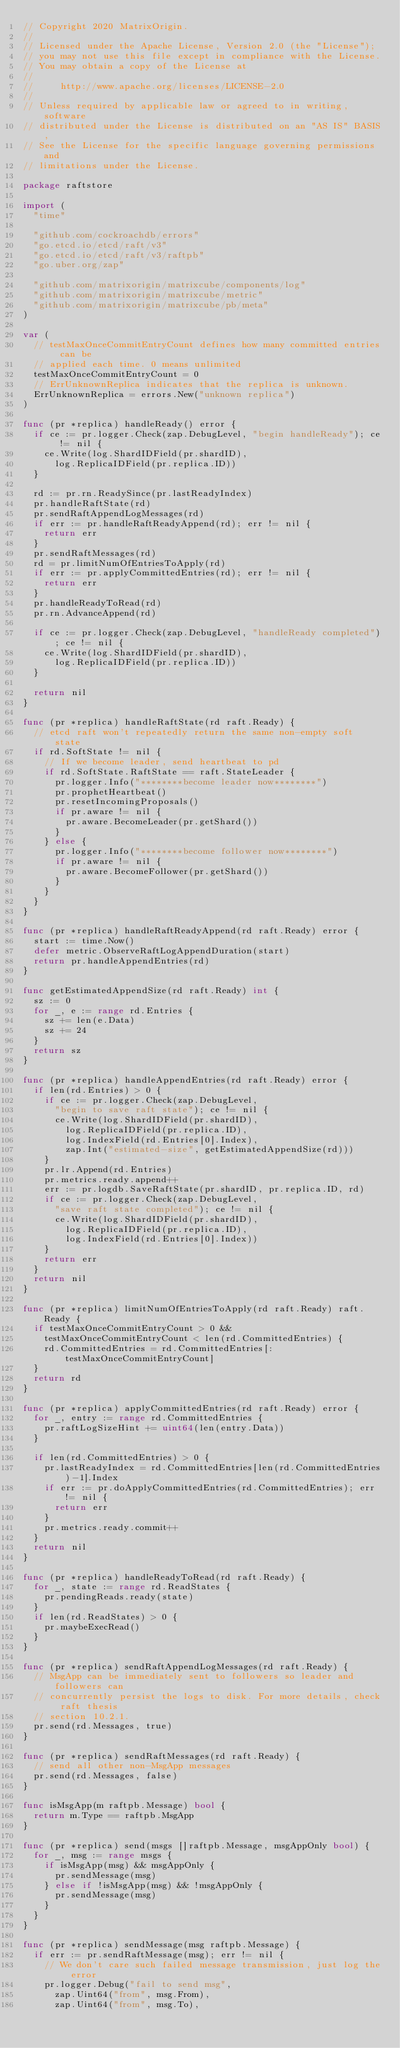Convert code to text. <code><loc_0><loc_0><loc_500><loc_500><_Go_>// Copyright 2020 MatrixOrigin.
//
// Licensed under the Apache License, Version 2.0 (the "License");
// you may not use this file except in compliance with the License.
// You may obtain a copy of the License at
//
//     http://www.apache.org/licenses/LICENSE-2.0
//
// Unless required by applicable law or agreed to in writing, software
// distributed under the License is distributed on an "AS IS" BASIS,
// See the License for the specific language governing permissions and
// limitations under the License.

package raftstore

import (
	"time"

	"github.com/cockroachdb/errors"
	"go.etcd.io/etcd/raft/v3"
	"go.etcd.io/etcd/raft/v3/raftpb"
	"go.uber.org/zap"

	"github.com/matrixorigin/matrixcube/components/log"
	"github.com/matrixorigin/matrixcube/metric"
	"github.com/matrixorigin/matrixcube/pb/meta"
)

var (
	// testMaxOnceCommitEntryCount defines how many committed entries can be
	// applied each time. 0 means unlimited
	testMaxOnceCommitEntryCount = 0
	// ErrUnknownReplica indicates that the replica is unknown.
	ErrUnknownReplica = errors.New("unknown replica")
)

func (pr *replica) handleReady() error {
	if ce := pr.logger.Check(zap.DebugLevel, "begin handleReady"); ce != nil {
		ce.Write(log.ShardIDField(pr.shardID),
			log.ReplicaIDField(pr.replica.ID))
	}

	rd := pr.rn.ReadySince(pr.lastReadyIndex)
	pr.handleRaftState(rd)
	pr.sendRaftAppendLogMessages(rd)
	if err := pr.handleRaftReadyAppend(rd); err != nil {
		return err
	}
	pr.sendRaftMessages(rd)
	rd = pr.limitNumOfEntriesToApply(rd)
	if err := pr.applyCommittedEntries(rd); err != nil {
		return err
	}
	pr.handleReadyToRead(rd)
	pr.rn.AdvanceAppend(rd)

	if ce := pr.logger.Check(zap.DebugLevel, "handleReady completed"); ce != nil {
		ce.Write(log.ShardIDField(pr.shardID),
			log.ReplicaIDField(pr.replica.ID))
	}

	return nil
}

func (pr *replica) handleRaftState(rd raft.Ready) {
	// etcd raft won't repeatedly return the same non-empty soft state
	if rd.SoftState != nil {
		// If we become leader, send heartbeat to pd
		if rd.SoftState.RaftState == raft.StateLeader {
			pr.logger.Info("********become leader now********")
			pr.prophetHeartbeat()
			pr.resetIncomingProposals()
			if pr.aware != nil {
				pr.aware.BecomeLeader(pr.getShard())
			}
		} else {
			pr.logger.Info("********become follower now********")
			if pr.aware != nil {
				pr.aware.BecomeFollower(pr.getShard())
			}
		}
	}
}

func (pr *replica) handleRaftReadyAppend(rd raft.Ready) error {
	start := time.Now()
	defer metric.ObserveRaftLogAppendDuration(start)
	return pr.handleAppendEntries(rd)
}

func getEstimatedAppendSize(rd raft.Ready) int {
	sz := 0
	for _, e := range rd.Entries {
		sz += len(e.Data)
		sz += 24
	}
	return sz
}

func (pr *replica) handleAppendEntries(rd raft.Ready) error {
	if len(rd.Entries) > 0 {
		if ce := pr.logger.Check(zap.DebugLevel,
			"begin to save raft state"); ce != nil {
			ce.Write(log.ShardIDField(pr.shardID),
				log.ReplicaIDField(pr.replica.ID),
				log.IndexField(rd.Entries[0].Index),
				zap.Int("estimated-size", getEstimatedAppendSize(rd)))
		}
		pr.lr.Append(rd.Entries)
		pr.metrics.ready.append++
		err := pr.logdb.SaveRaftState(pr.shardID, pr.replica.ID, rd)
		if ce := pr.logger.Check(zap.DebugLevel,
			"save raft state completed"); ce != nil {
			ce.Write(log.ShardIDField(pr.shardID),
				log.ReplicaIDField(pr.replica.ID),
				log.IndexField(rd.Entries[0].Index))
		}
		return err
	}
	return nil
}

func (pr *replica) limitNumOfEntriesToApply(rd raft.Ready) raft.Ready {
	if testMaxOnceCommitEntryCount > 0 &&
		testMaxOnceCommitEntryCount < len(rd.CommittedEntries) {
		rd.CommittedEntries = rd.CommittedEntries[:testMaxOnceCommitEntryCount]
	}
	return rd
}

func (pr *replica) applyCommittedEntries(rd raft.Ready) error {
	for _, entry := range rd.CommittedEntries {
		pr.raftLogSizeHint += uint64(len(entry.Data))
	}

	if len(rd.CommittedEntries) > 0 {
		pr.lastReadyIndex = rd.CommittedEntries[len(rd.CommittedEntries)-1].Index
		if err := pr.doApplyCommittedEntries(rd.CommittedEntries); err != nil {
			return err
		}
		pr.metrics.ready.commit++
	}
	return nil
}

func (pr *replica) handleReadyToRead(rd raft.Ready) {
	for _, state := range rd.ReadStates {
		pr.pendingReads.ready(state)
	}
	if len(rd.ReadStates) > 0 {
		pr.maybeExecRead()
	}
}

func (pr *replica) sendRaftAppendLogMessages(rd raft.Ready) {
	// MsgApp can be immediately sent to followers so leader and followers can
	// concurrently persist the logs to disk. For more details, check raft thesis
	// section 10.2.1.
	pr.send(rd.Messages, true)
}

func (pr *replica) sendRaftMessages(rd raft.Ready) {
	// send all other non-MsgApp messages
	pr.send(rd.Messages, false)
}

func isMsgApp(m raftpb.Message) bool {
	return m.Type == raftpb.MsgApp
}

func (pr *replica) send(msgs []raftpb.Message, msgAppOnly bool) {
	for _, msg := range msgs {
		if isMsgApp(msg) && msgAppOnly {
			pr.sendMessage(msg)
		} else if !isMsgApp(msg) && !msgAppOnly {
			pr.sendMessage(msg)
		}
	}
}

func (pr *replica) sendMessage(msg raftpb.Message) {
	if err := pr.sendRaftMessage(msg); err != nil {
		// We don't care such failed message transmission, just log the error
		pr.logger.Debug("fail to send msg",
			zap.Uint64("from", msg.From),
			zap.Uint64("from", msg.To),</code> 